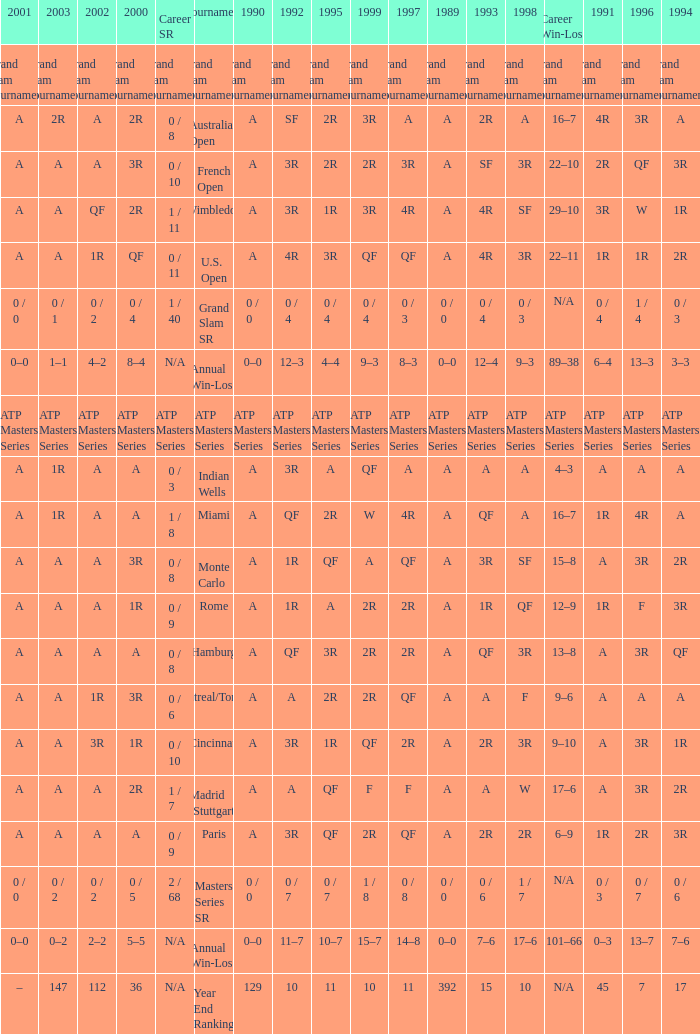What is the worth in 1997 when the worth in 1989 is a, 1995 is qf, 1996 is 3r and the career sr is 0 / 8? QF. 